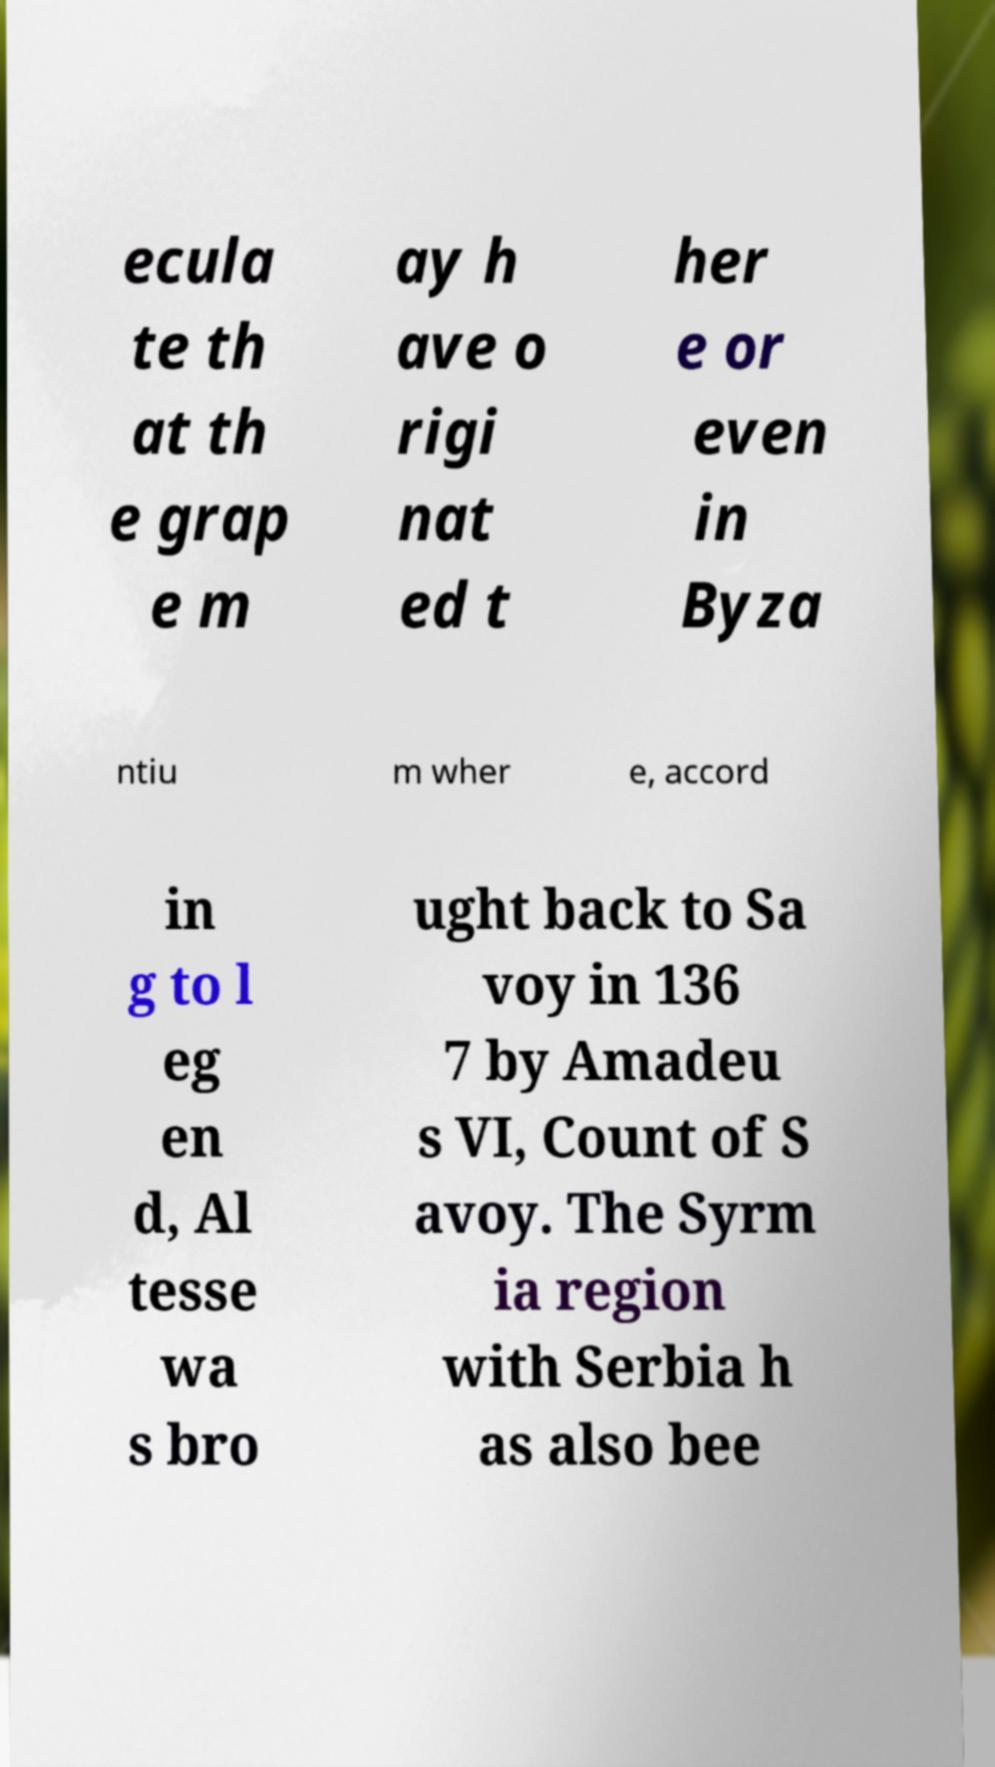Could you assist in decoding the text presented in this image and type it out clearly? ecula te th at th e grap e m ay h ave o rigi nat ed t her e or even in Byza ntiu m wher e, accord in g to l eg en d, Al tesse wa s bro ught back to Sa voy in 136 7 by Amadeu s VI, Count of S avoy. The Syrm ia region with Serbia h as also bee 